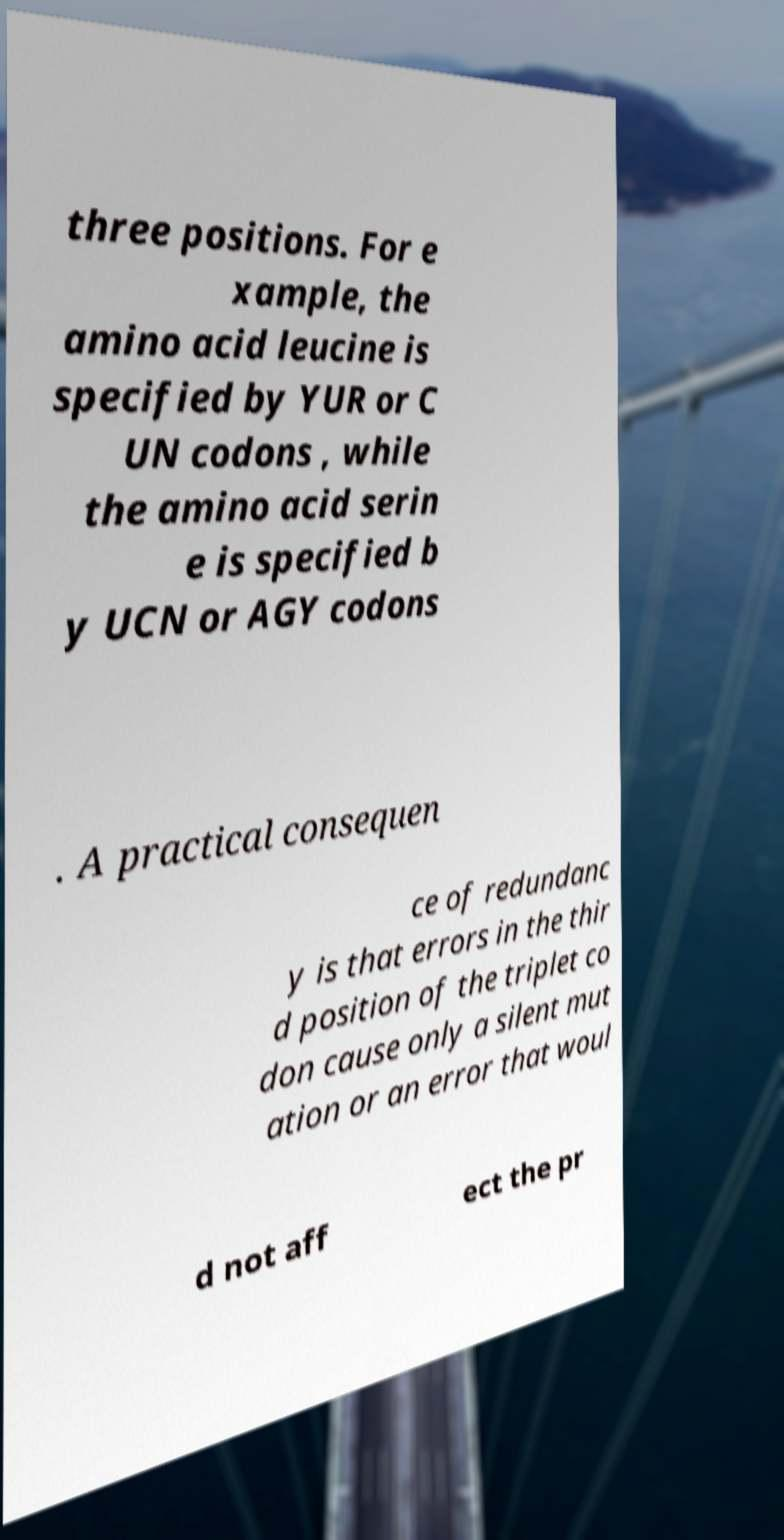Can you accurately transcribe the text from the provided image for me? three positions. For e xample, the amino acid leucine is specified by YUR or C UN codons , while the amino acid serin e is specified b y UCN or AGY codons . A practical consequen ce of redundanc y is that errors in the thir d position of the triplet co don cause only a silent mut ation or an error that woul d not aff ect the pr 